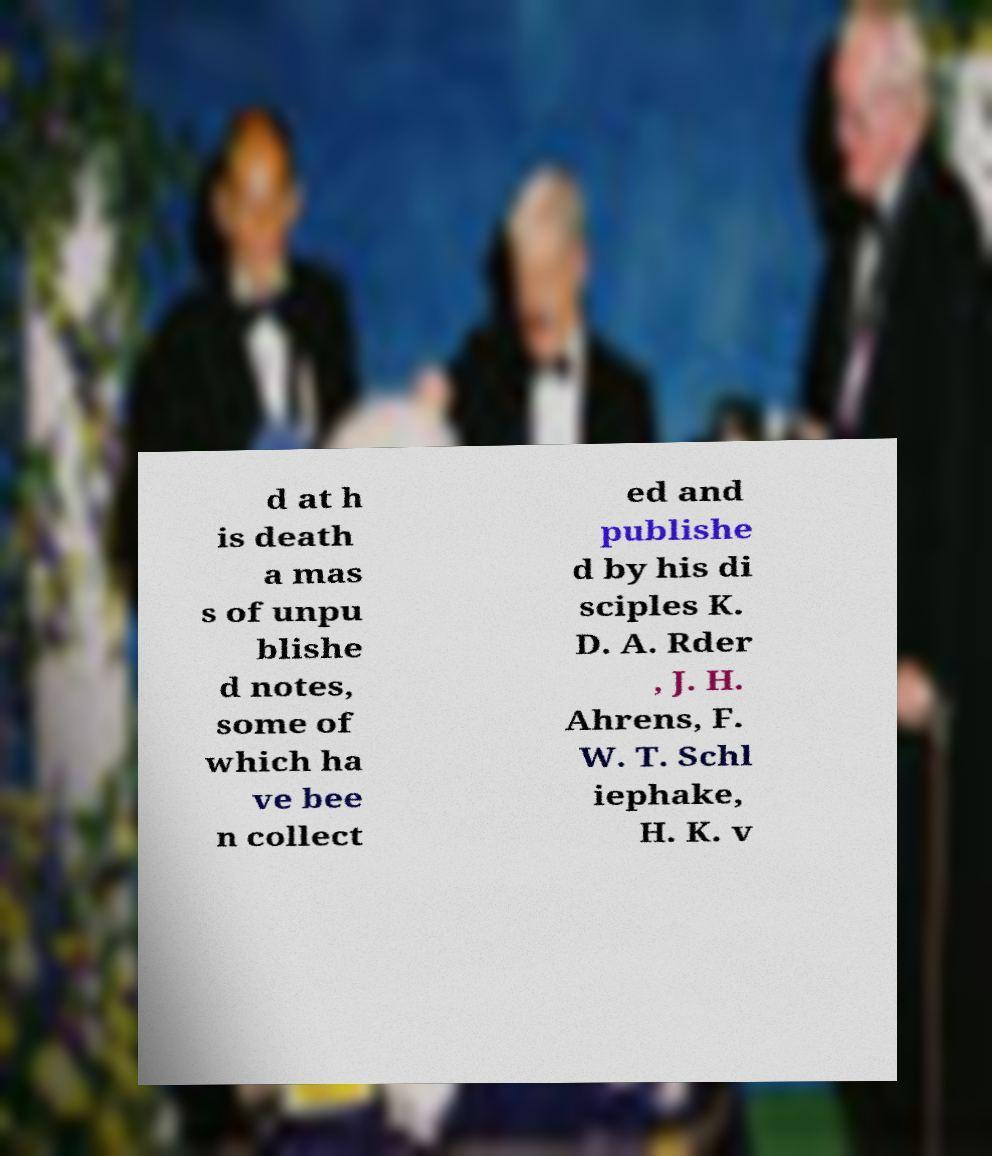Can you accurately transcribe the text from the provided image for me? d at h is death a mas s of unpu blishe d notes, some of which ha ve bee n collect ed and publishe d by his di sciples K. D. A. Rder , J. H. Ahrens, F. W. T. Schl iephake, H. K. v 